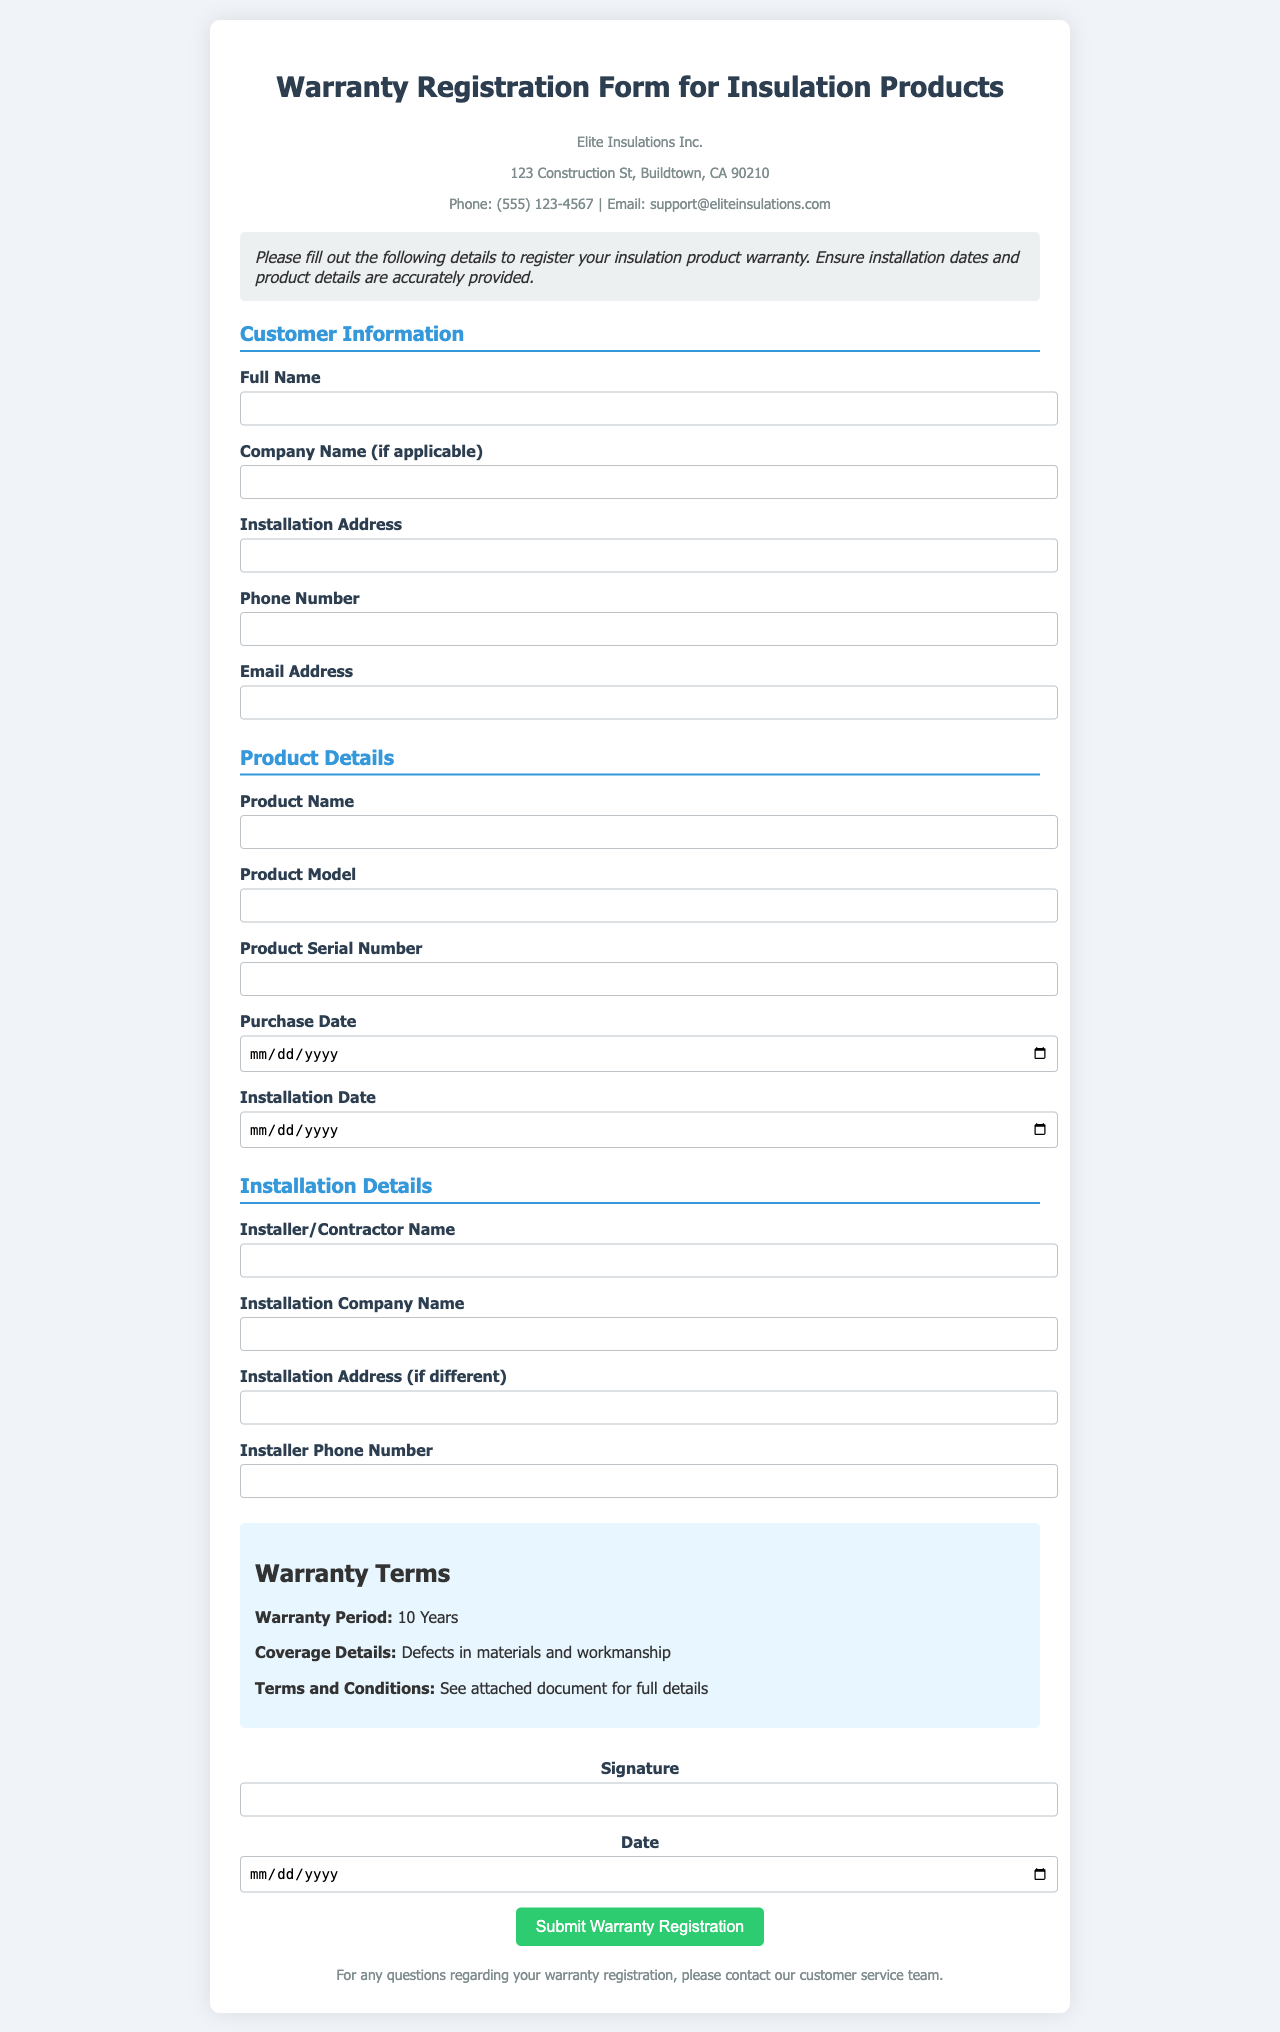what is the company name? The company name is specified at the top of the document as Elite Insulations Inc.
Answer: Elite Insulations Inc what is the warranty period for the insulation products? The warranty period is mentioned under the Warranty Terms section of the document.
Answer: 10 Years what is the phone number for customer support? The phone number for customer support is provided in the company information section.
Answer: (555) 123-4567 what details are covered by the warranty? Coverage details are outlined in the Warranty Terms section, indicating what defects are included.
Answer: Defects in materials and workmanship who needs to be filled in as the installer/contractor? This is specified in the Installation Details section, indicating the required information.
Answer: Installer/Contractor Name what types of information are required in the Installation Company Name field? The document specifies that the name of the company responsible for installation is necessary.
Answer: Installation Company Name when is the installation date expected to be filled in? The installation date is required by the form as part of the Product Details section.
Answer: Installation Date where should the installation address be inputted? The installation address field is specifically labeled in the Customer Information section.
Answer: Installation Address what is required in the signature field? The signature field must be filled with the name of the person registering the warranty.
Answer: Signature 